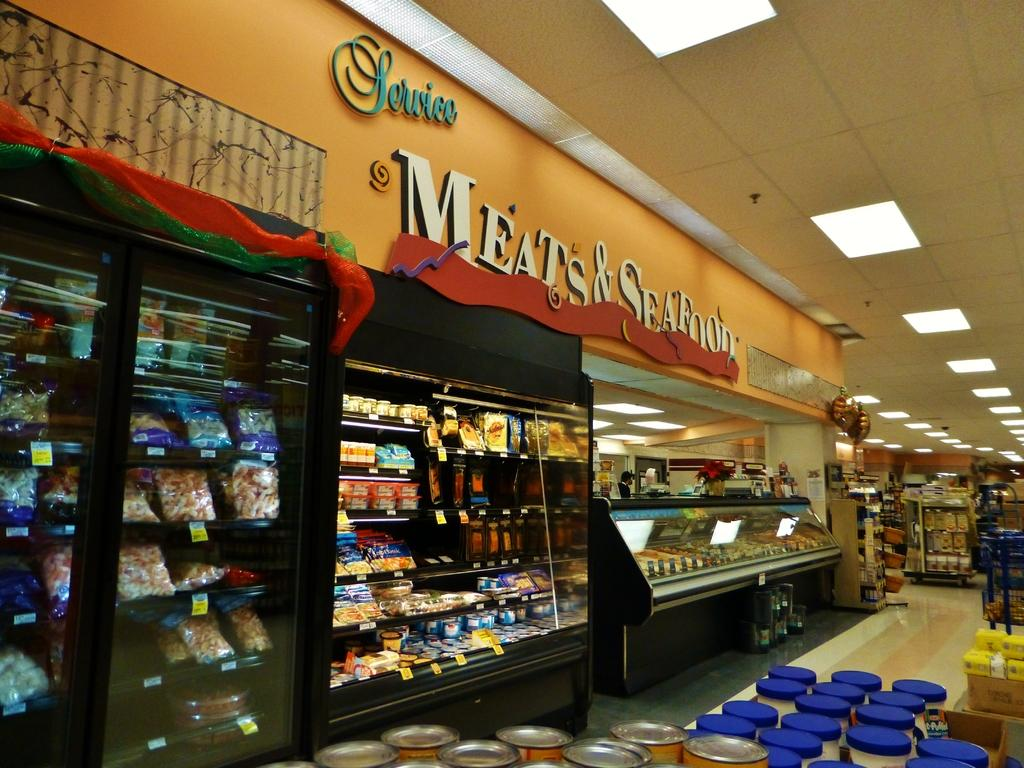<image>
Share a concise interpretation of the image provided. A section of a store with a sign saying "Meats & seafood". 